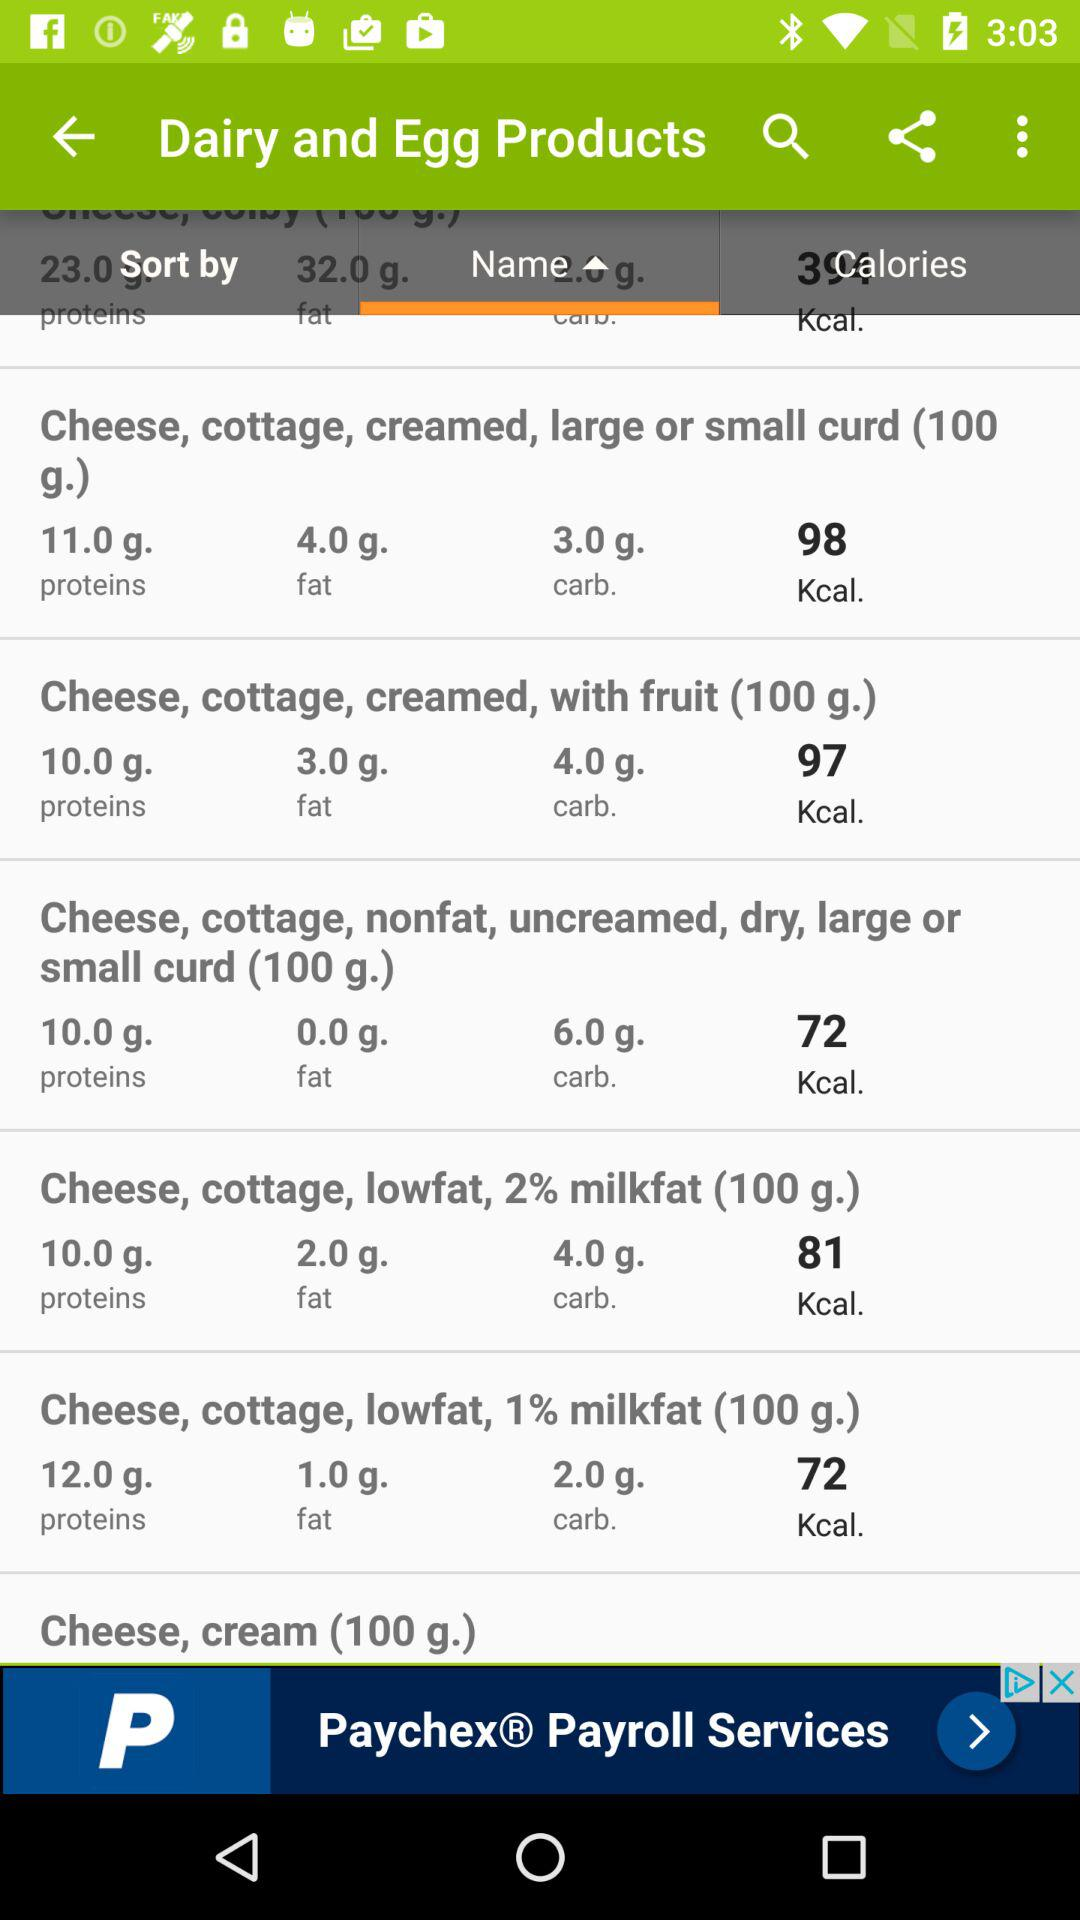What's the Kilocalorie amount in "Cheese, cottage, lowfat, 1% milkfat (100 g.)"? The amount is 72. 